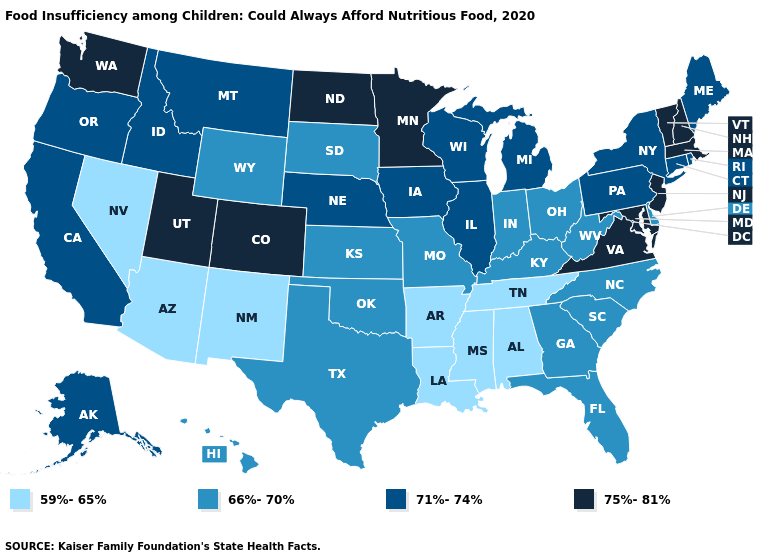What is the value of Maine?
Be succinct. 71%-74%. Among the states that border Nevada , does Utah have the highest value?
Keep it brief. Yes. Does New Mexico have the lowest value in the West?
Concise answer only. Yes. Name the states that have a value in the range 66%-70%?
Short answer required. Delaware, Florida, Georgia, Hawaii, Indiana, Kansas, Kentucky, Missouri, North Carolina, Ohio, Oklahoma, South Carolina, South Dakota, Texas, West Virginia, Wyoming. What is the value of Mississippi?
Answer briefly. 59%-65%. Does Massachusetts have a lower value than West Virginia?
Write a very short answer. No. What is the highest value in the USA?
Write a very short answer. 75%-81%. Name the states that have a value in the range 66%-70%?
Write a very short answer. Delaware, Florida, Georgia, Hawaii, Indiana, Kansas, Kentucky, Missouri, North Carolina, Ohio, Oklahoma, South Carolina, South Dakota, Texas, West Virginia, Wyoming. Name the states that have a value in the range 59%-65%?
Concise answer only. Alabama, Arizona, Arkansas, Louisiana, Mississippi, Nevada, New Mexico, Tennessee. What is the value of Alabama?
Write a very short answer. 59%-65%. Does Oregon have the same value as Hawaii?
Keep it brief. No. Name the states that have a value in the range 66%-70%?
Short answer required. Delaware, Florida, Georgia, Hawaii, Indiana, Kansas, Kentucky, Missouri, North Carolina, Ohio, Oklahoma, South Carolina, South Dakota, Texas, West Virginia, Wyoming. What is the value of Washington?
Answer briefly. 75%-81%. Does the first symbol in the legend represent the smallest category?
Short answer required. Yes. 